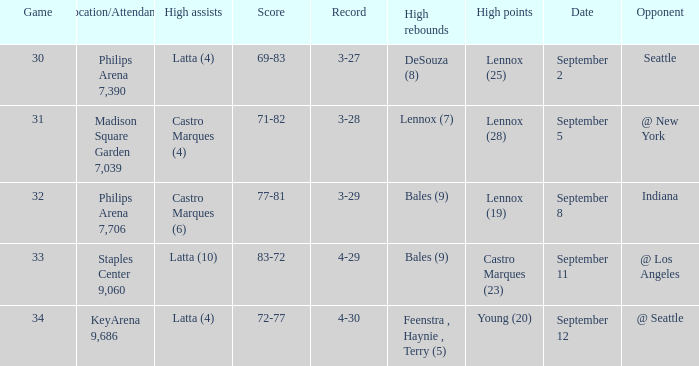What was the Location/Attendance on september 11? Staples Center 9,060. 